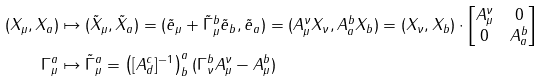<formula> <loc_0><loc_0><loc_500><loc_500>( X _ { \mu } , X _ { a } ) & \mapsto ( \tilde { X } _ { \mu } , \tilde { X } _ { a } ) = ( \tilde { e } _ { \mu } + \tilde { \Gamma } _ { \mu } ^ { b } \tilde { e } _ { b } , \tilde { e } _ { a } ) = ( A _ { \mu } ^ { \nu } X _ { \nu } , A _ { a } ^ { b } X _ { b } ) = ( X _ { \nu } , X _ { b } ) \cdot \begin{bmatrix} A _ { \mu } ^ { \nu } & 0 \\ 0 & A _ { a } ^ { b } \end{bmatrix} \\ \Gamma _ { \mu } ^ { a } & \mapsto \tilde { \Gamma } _ { \mu } ^ { a } = \left ( [ A _ { d } ^ { c } ] ^ { - 1 } \right ) _ { b } ^ { a } ( \Gamma _ { \nu } ^ { b } A _ { \mu } ^ { \nu } - A _ { \mu } ^ { b } )</formula> 